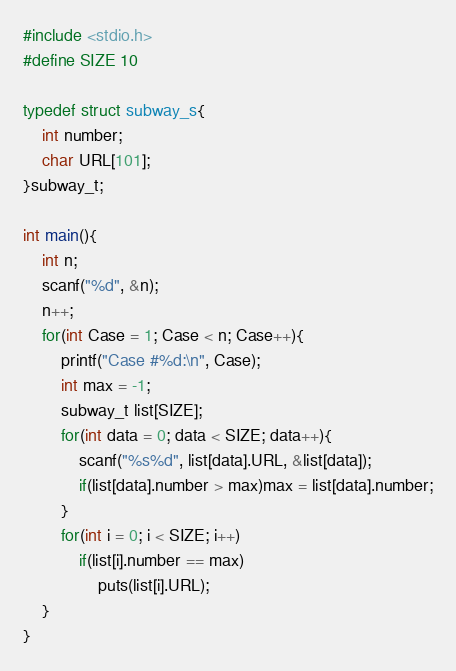<code> <loc_0><loc_0><loc_500><loc_500><_C_>#include <stdio.h>
#define SIZE 10

typedef struct subway_s{
    int number;
    char URL[101];
}subway_t;

int main(){
    int n;
    scanf("%d", &n);
    n++;
    for(int Case = 1; Case < n; Case++){
        printf("Case #%d:\n", Case);
        int max = -1;
        subway_t list[SIZE];
        for(int data = 0; data < SIZE; data++){
            scanf("%s%d", list[data].URL, &list[data]);
            if(list[data].number > max)max = list[data].number;
        }
        for(int i = 0; i < SIZE; i++)
            if(list[i].number == max)
                puts(list[i].URL);
    }
}
</code> 